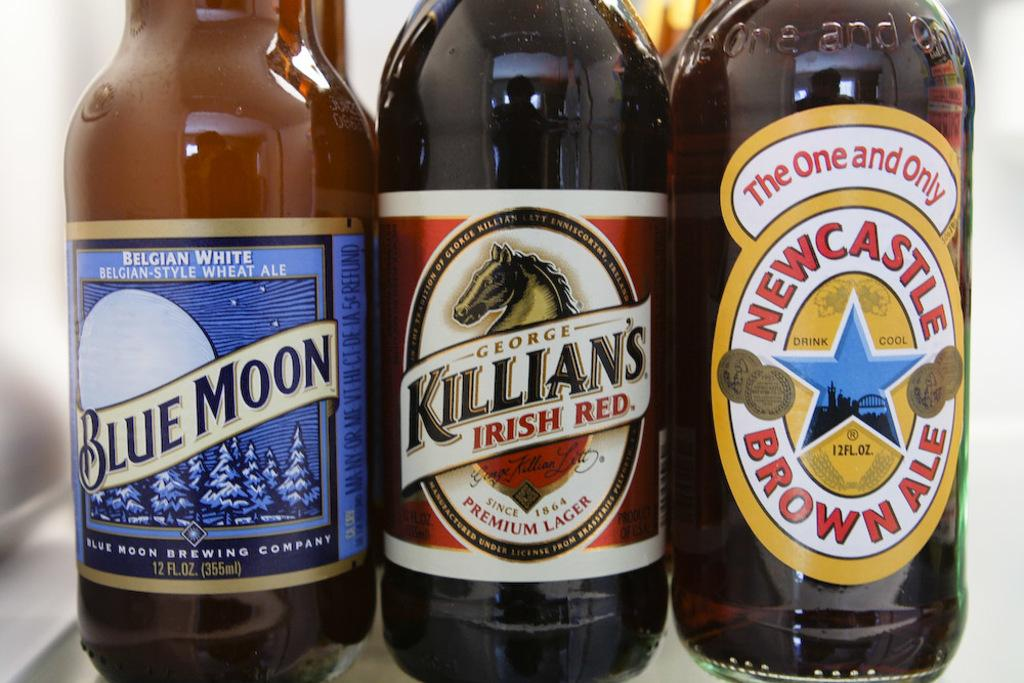<image>
Provide a brief description of the given image. three bottles of beer lined up include Blue Moon 